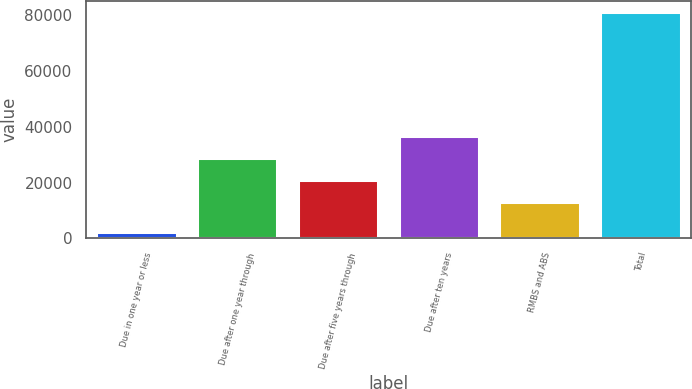Convert chart to OTSL. <chart><loc_0><loc_0><loc_500><loc_500><bar_chart><fcel>Due in one year or less<fcel>Due after one year through<fcel>Due after five years through<fcel>Due after ten years<fcel>RMBS and ABS<fcel>Total<nl><fcel>2264<fcel>28796.8<fcel>20898.9<fcel>36694.7<fcel>13001<fcel>81243<nl></chart> 